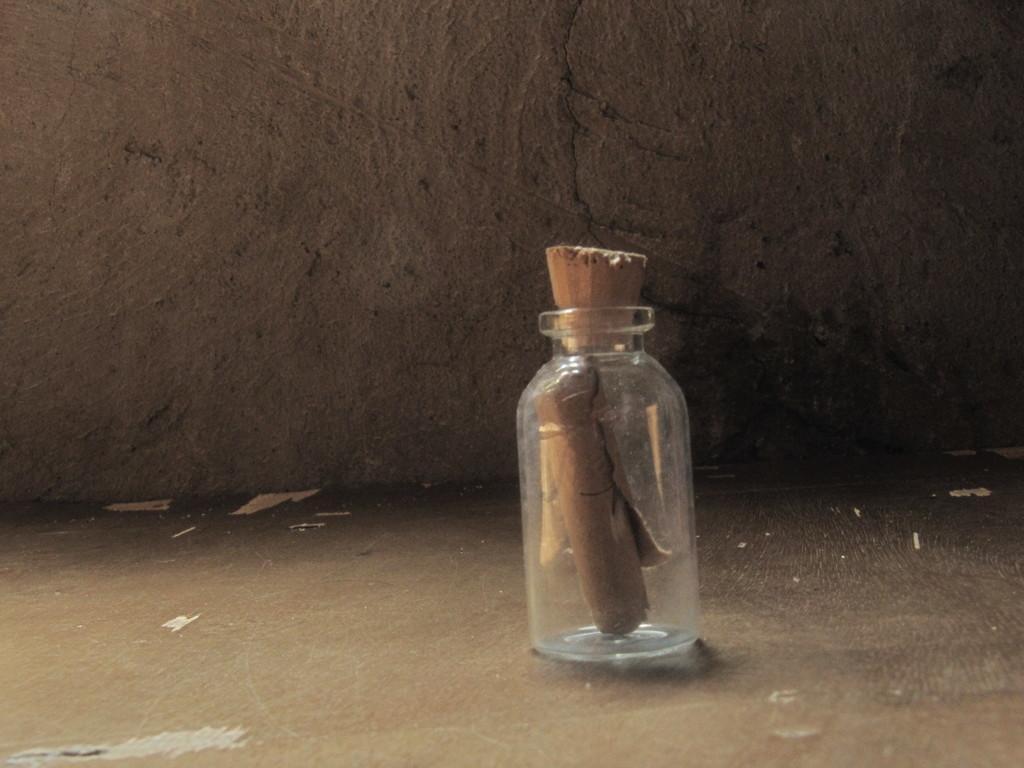In one or two sentences, can you explain what this image depicts? This picture is mainly highlighted with a glass jar in which we can see a wood is inserted. On the background we can see a wall. 